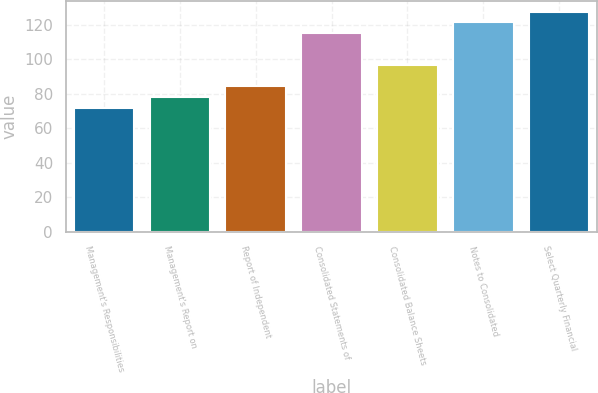<chart> <loc_0><loc_0><loc_500><loc_500><bar_chart><fcel>Management's Responsibilities<fcel>Management's Report on<fcel>Report of Independent<fcel>Consolidated Statements of<fcel>Consolidated Balance Sheets<fcel>Notes to Consolidated<fcel>Select Quarterly Financial<nl><fcel>72<fcel>78.2<fcel>84.4<fcel>115.4<fcel>96.8<fcel>121.6<fcel>127.8<nl></chart> 